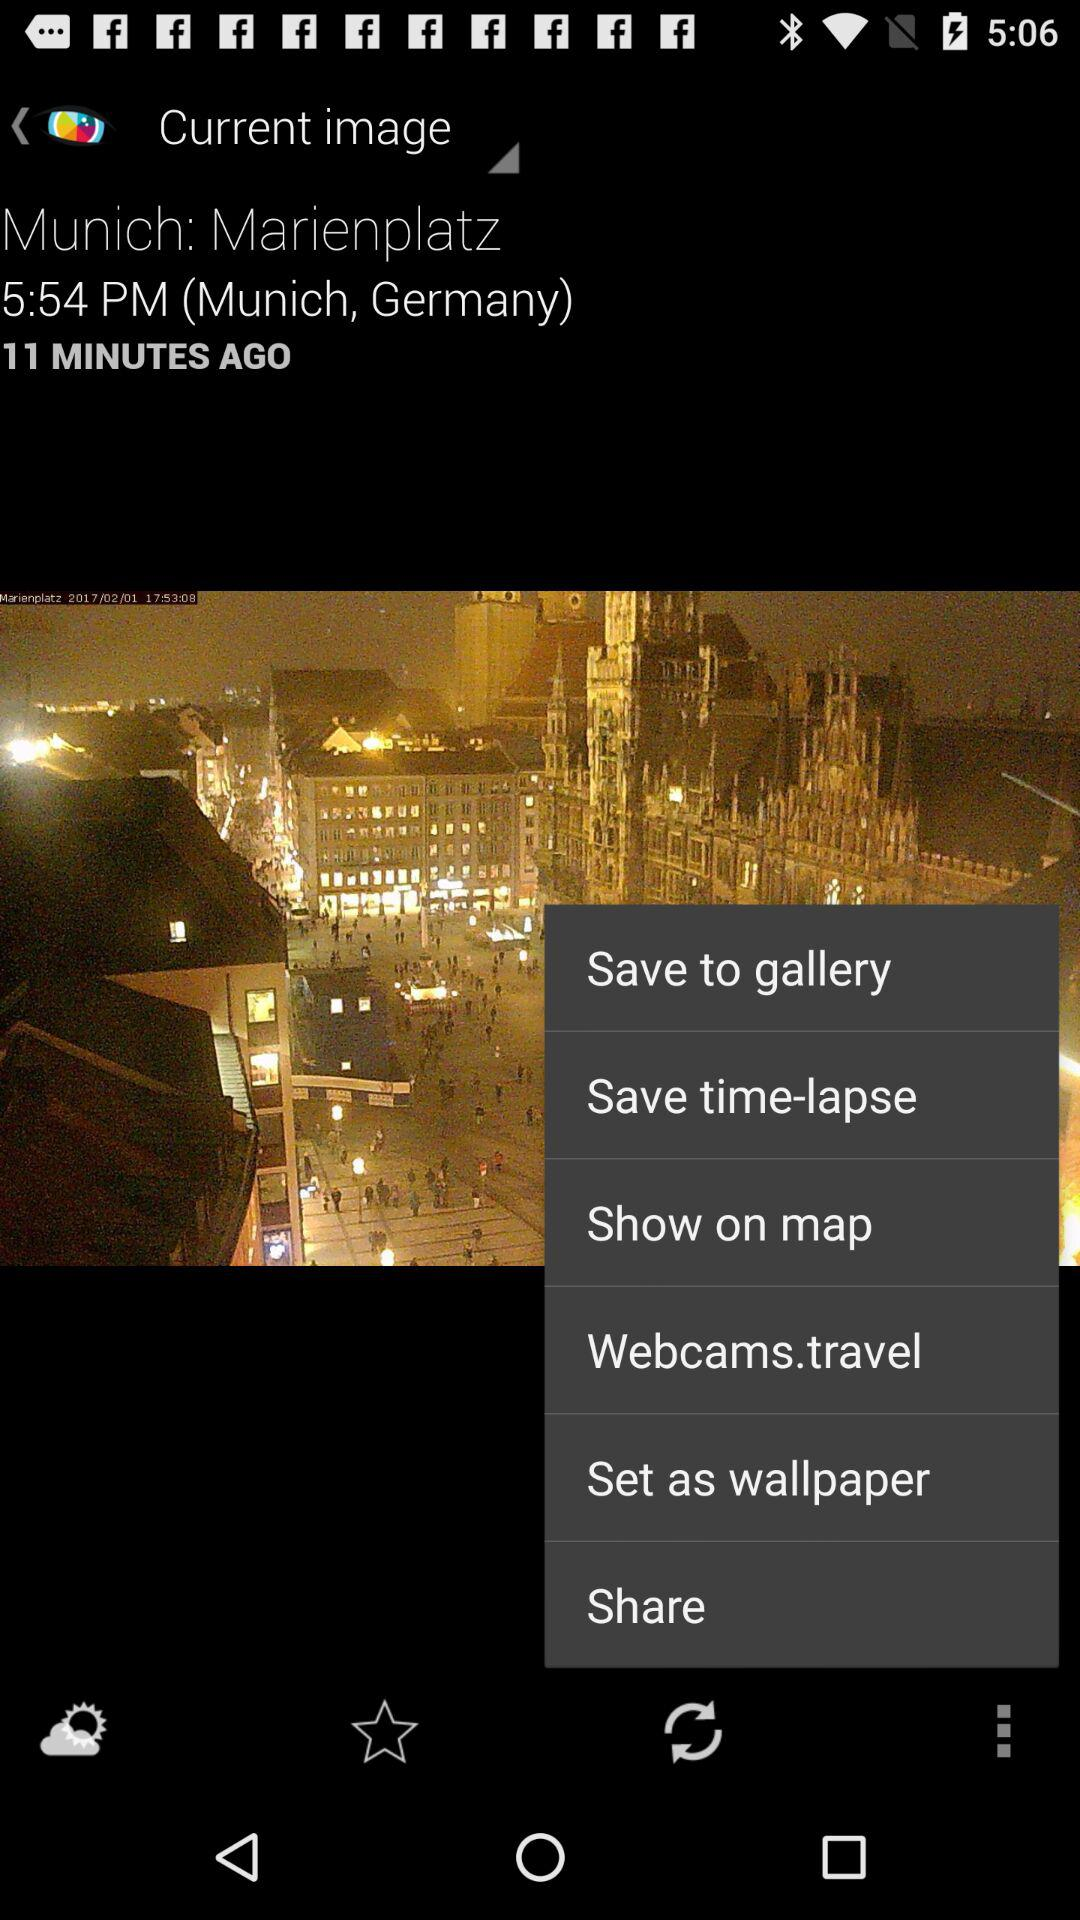What is the mentioned time? The mentioned time is 5:54 PM. 